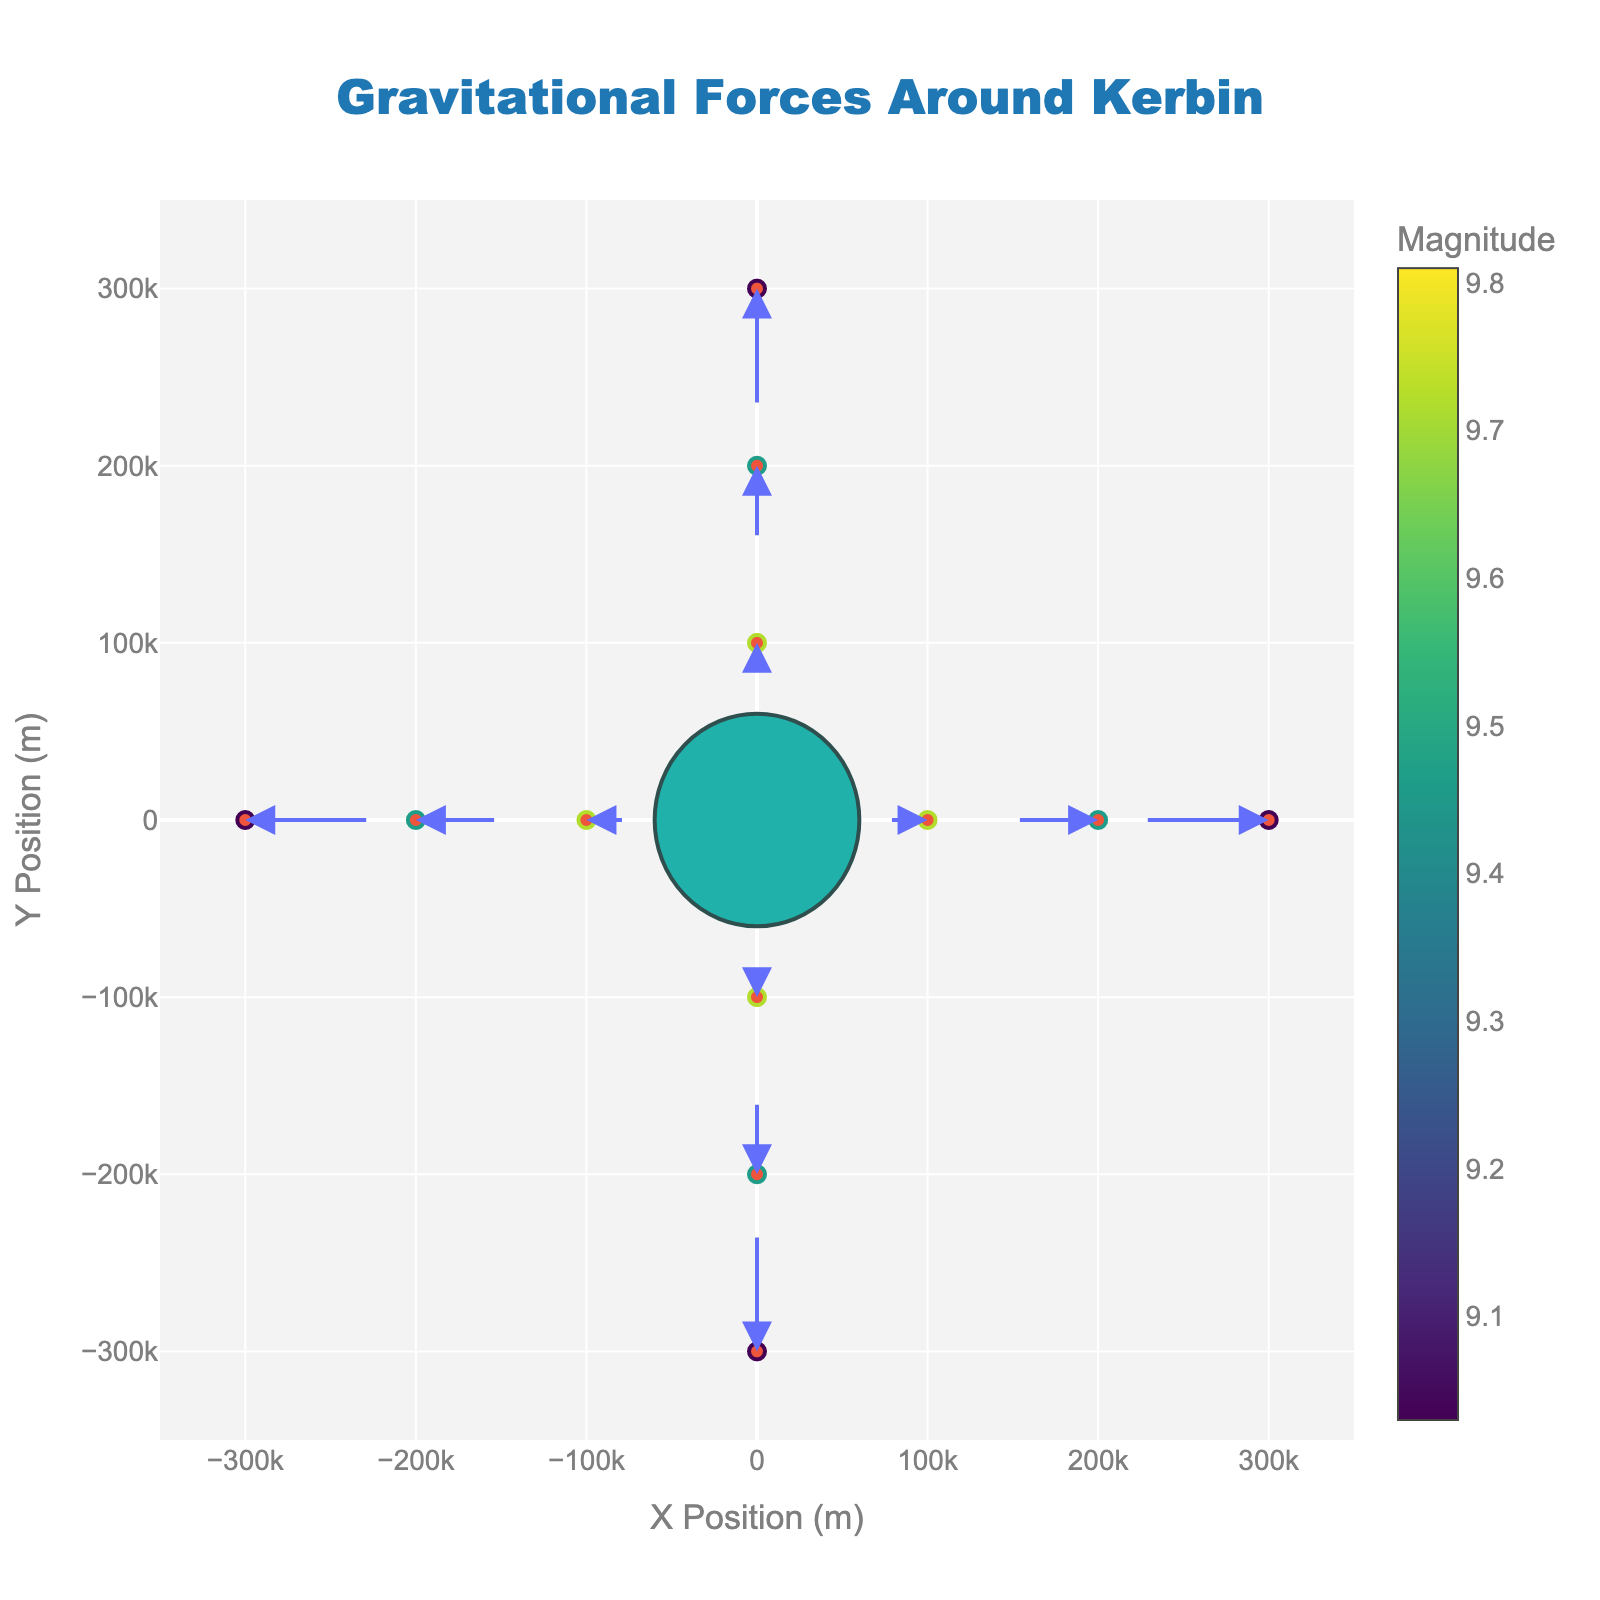What is the title of the figure? Look at the text at the top center of the figure, it serves as the title.
Answer: Gravitational Forces Around Kerbin What is the color used to represent the magnitude of gravitational force? The colors used are from the Viridis color scale, which ranges from dark purple to yellow.
Answer: Various shades from purple to yellow How many data points are displayed in the figure? Count the number of arrows or markers representing data points in the figure.
Answer: 13 What is the x and y position of the data point with the highest magnitude? Identify the data point with the most intense color and note its x and y coordinates. The center point usually represents the highest magnitude in this context.
Answer: (0, 0) Which data point has the lowest magnitude and what are its coordinates? Find the point with the least intense color in the Viridis color scale and read its x and y coordinates.
Answer: The edge points (300000,0), (0,300000), (-300000,0), (0,-300000) What is the general direction of the gravitational force vectors? Observe the direction of the arrows at various data points and generalize their direction.
Answer: Towards the center (Kerbin) What is the magnitude of the gravitational force at (100,000, 0)? Find the corresponding data point and look for the text or color indicating its magnitude.
Answer: 9.72 Compare the magnitudes of gravitational forces at (200,000, 0) and (300,000, 0). Which one is stronger? Look at the colors and/or hover text values of the two data points and compare them.
Answer: The force at (200,000, 0) is stronger What happens to the magnitude of gravitational force as you move away from Kerbin? Analyze the trend by observing the colors and the magnitude values on arrows farther from the center.
Answer: It decreases How do the gravitational vectors differ at (0, 100,000) and (100,000, 0)? Compare the lengths and directions of the arrows at these two points.
Answer: They have the same magnitude but different directions (pointing toward the center from their respective axes) 